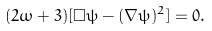Convert formula to latex. <formula><loc_0><loc_0><loc_500><loc_500>( 2 \omega + 3 ) [ \Box \psi - ( \nabla \psi ) ^ { 2 } ] = 0 .</formula> 